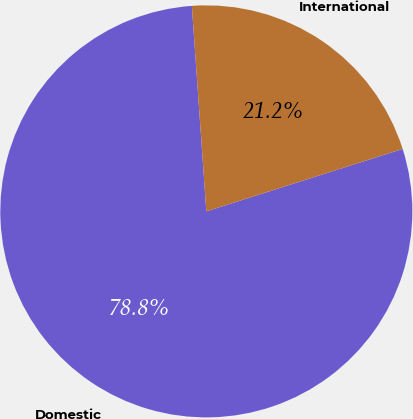Convert chart. <chart><loc_0><loc_0><loc_500><loc_500><pie_chart><fcel>Domestic<fcel>International<nl><fcel>78.78%<fcel>21.22%<nl></chart> 